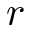<formula> <loc_0><loc_0><loc_500><loc_500>r</formula> 